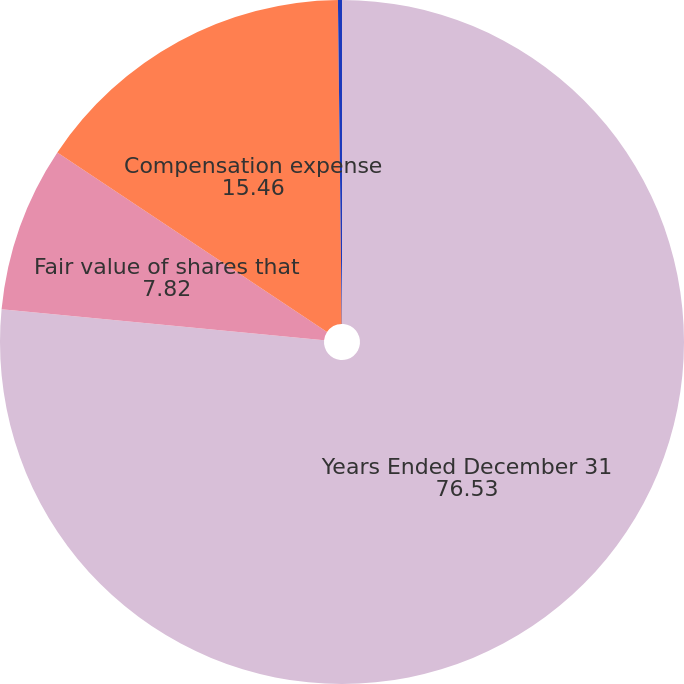Convert chart to OTSL. <chart><loc_0><loc_0><loc_500><loc_500><pie_chart><fcel>Years Ended December 31<fcel>Fair value of shares that<fcel>Compensation expense<fcel>Income tax benefit recognized<nl><fcel>76.53%<fcel>7.82%<fcel>15.46%<fcel>0.19%<nl></chart> 